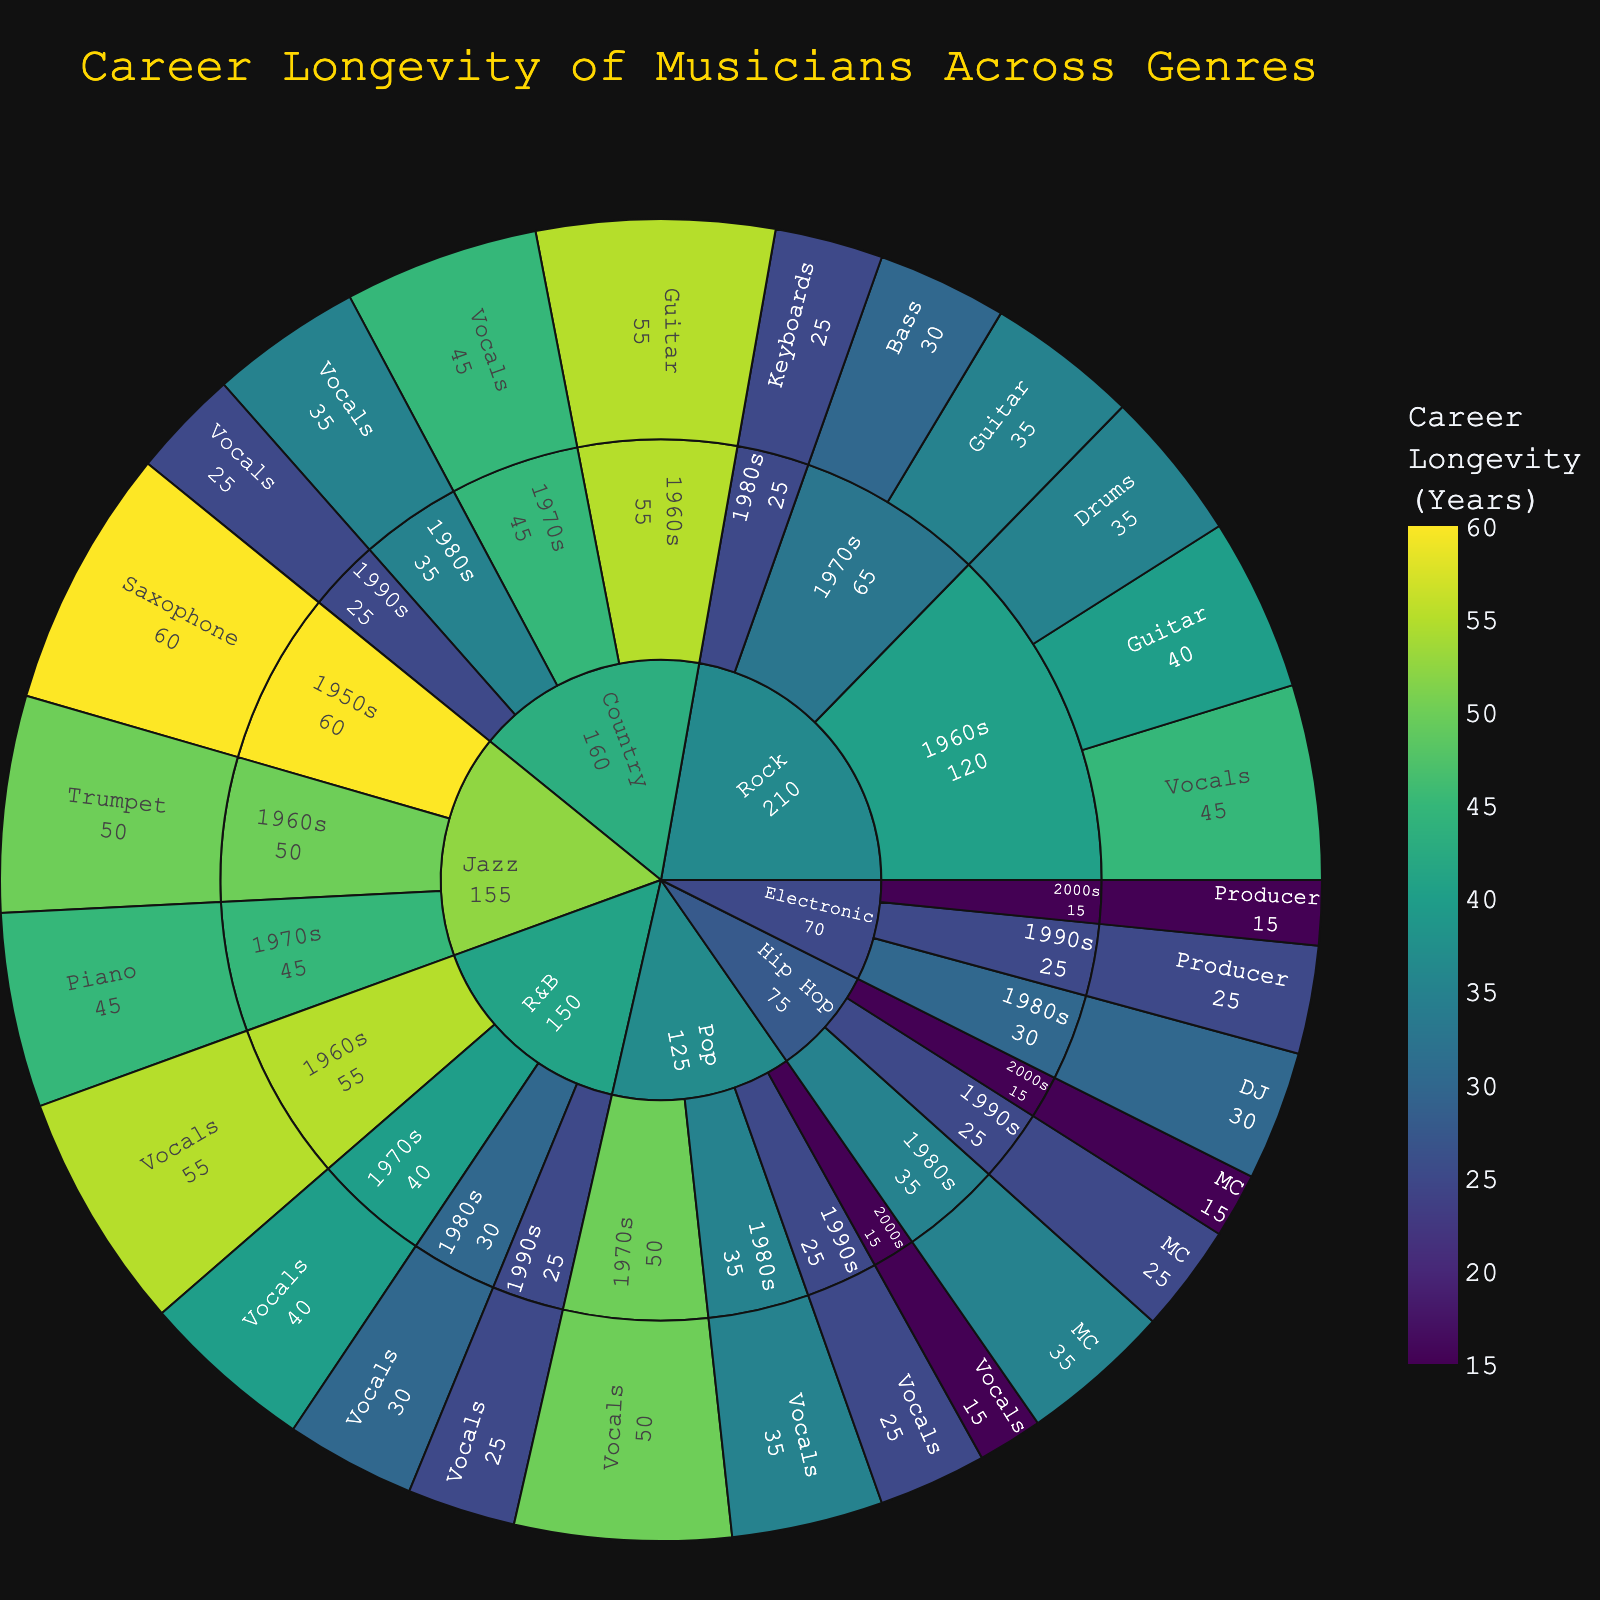What genre has the longest overall career longevity? By looking at the outermost layer of the sunburst plot, identify which genre has the highest longevity value.
Answer: Jazz Which decade saw the longest career longevity for Pop vocals? Within the Pop genre, find the decade segment for vocals and observe its associated longevity value.
Answer: 1970s How does the career longevity of Jazz Saxophonists in the 1950s compare to R&B vocalists from the 1960s? Compare the segment values for Jazz Saxophonists from the 1950s and R&B vocalists from the 1960s on the plot.
Answer: Both are 60 years What is the average longevity of Rock musicians who debuted in the 1960s? Sum the longevity of Rock musicians from the 1960s and divide by the number of data points in that segment. (40 + 35 + 45) / 3 = 40
Answer: 40 How does the career longevity of Electronic DJs in the 1980s compare to Electronic Producers in the 2000s? Identify the segment values for Electronic DJs in the 1980s and Electronic Producers in the 2000s and compare them.
Answer: DJs: 30, Producers: 15 Which instrument specialization within the Country genre has the longest career longevity? Identify the longest segment value within the Country genre when broken down by instrument specialization.
Answer: Guitar Is the career longevity of Hip Hop MCs increasing or decreasing over the decades? Observe the longevity values for Hip Hop MCs across the 1980s, 1990s, and 2000s.
Answer: Decreasing What is the combined longevity of all Rock guitarists from the 1960s and 1970s? Add the longevity values of Rock guitarists from the 1960s and 1970s. 40 + 35 = 75
Answer: 75 Which decade has the highest career longevity within the R&B genre? Observe the longevity values segmented by decade within the R&B genre and identify the highest value.
Answer: 1960s How does the average career longevity of musicians debuting in the 1970s compare across the Pop and R&B genres? Calculate the average longevity for Pop and R&B musicians from the 1970s and compare. Pop: 50, R&B: 40
Answer: Pop has higher average 